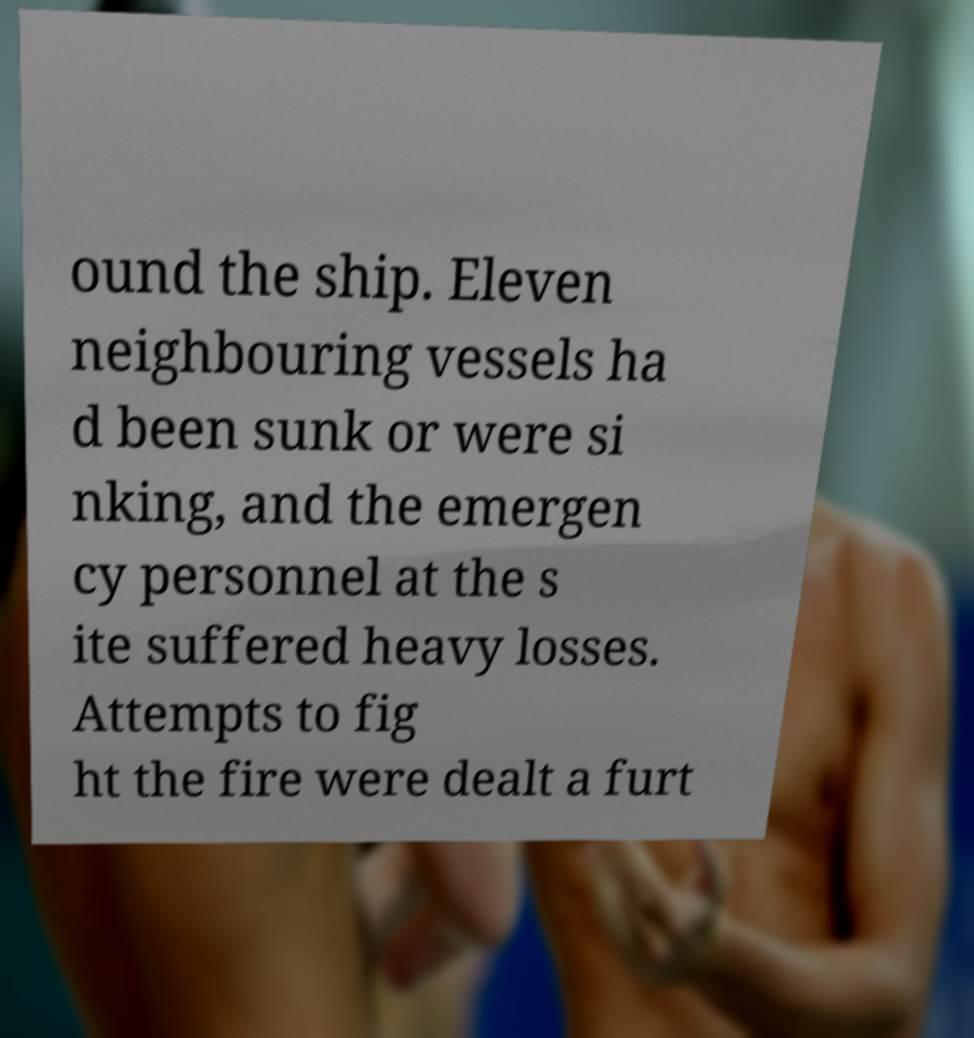For documentation purposes, I need the text within this image transcribed. Could you provide that? ound the ship. Eleven neighbouring vessels ha d been sunk or were si nking, and the emergen cy personnel at the s ite suffered heavy losses. Attempts to fig ht the fire were dealt a furt 